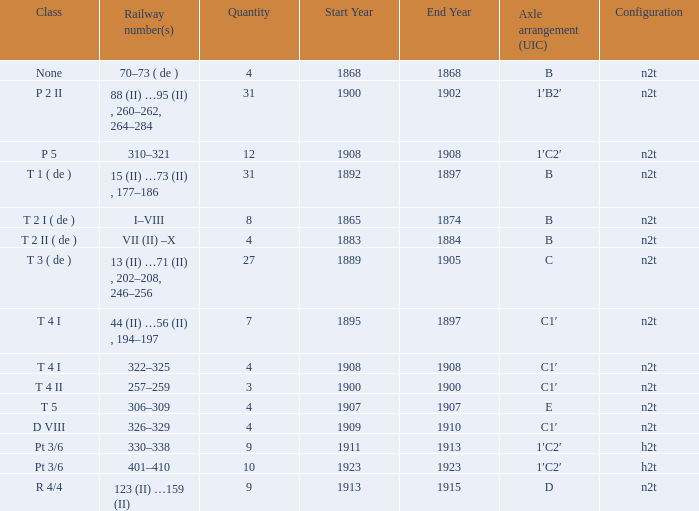What is the railway number of t 4 ii class? 257–259. 